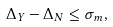<formula> <loc_0><loc_0><loc_500><loc_500>\Delta _ { Y } - \Delta _ { N } \leq \sigma _ { m } ,</formula> 